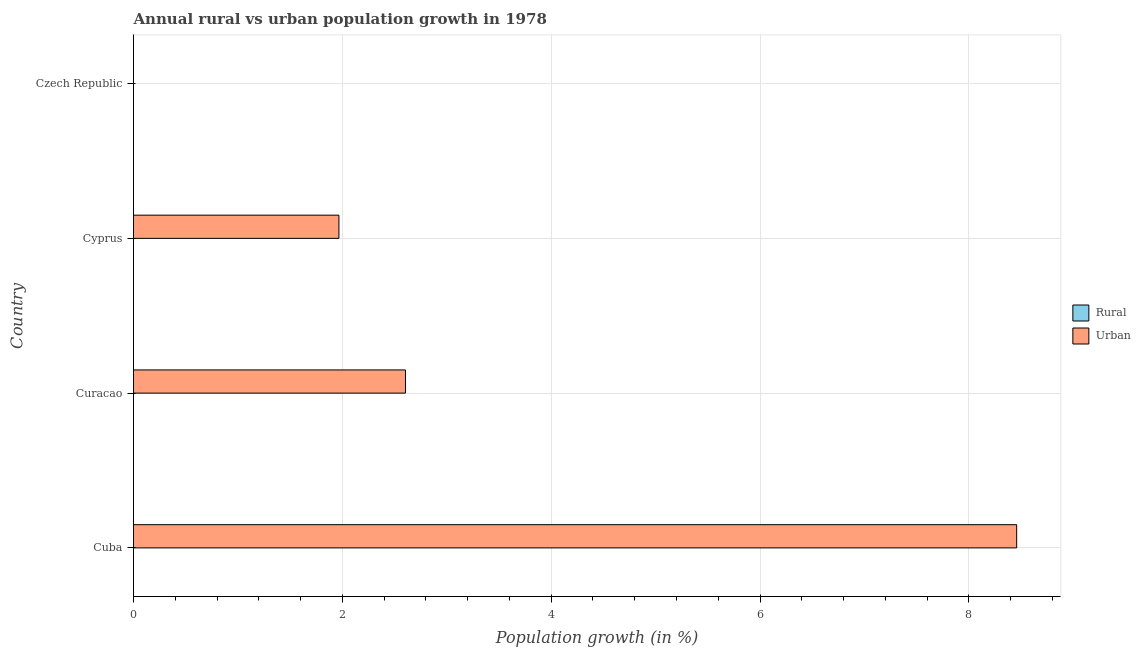How many different coloured bars are there?
Provide a succinct answer. 1. Are the number of bars per tick equal to the number of legend labels?
Your answer should be compact. No. How many bars are there on the 2nd tick from the bottom?
Offer a very short reply. 1. What is the label of the 1st group of bars from the top?
Ensure brevity in your answer.  Czech Republic. In how many cases, is the number of bars for a given country not equal to the number of legend labels?
Make the answer very short. 4. What is the urban population growth in Curacao?
Your answer should be compact. 2.6. Across all countries, what is the maximum urban population growth?
Offer a very short reply. 8.46. Across all countries, what is the minimum urban population growth?
Offer a very short reply. 0. In which country was the urban population growth maximum?
Your answer should be very brief. Cuba. What is the total urban population growth in the graph?
Your answer should be very brief. 13.03. What is the difference between the urban population growth in Curacao and that in Cyprus?
Offer a very short reply. 0.64. What is the difference between the urban population growth in Curacao and the rural population growth in Cuba?
Ensure brevity in your answer.  2.6. In how many countries, is the rural population growth greater than 2 %?
Give a very brief answer. 0. What is the difference between the highest and the second highest urban population growth?
Your response must be concise. 5.85. What is the difference between the highest and the lowest urban population growth?
Offer a terse response. 8.46. Is the sum of the urban population growth in Cuba and Cyprus greater than the maximum rural population growth across all countries?
Offer a terse response. Yes. How many bars are there?
Your answer should be very brief. 3. Are all the bars in the graph horizontal?
Offer a very short reply. Yes. How many countries are there in the graph?
Provide a succinct answer. 4. What is the difference between two consecutive major ticks on the X-axis?
Your answer should be compact. 2. Where does the legend appear in the graph?
Ensure brevity in your answer.  Center right. How are the legend labels stacked?
Give a very brief answer. Vertical. What is the title of the graph?
Ensure brevity in your answer.  Annual rural vs urban population growth in 1978. What is the label or title of the X-axis?
Your answer should be compact. Population growth (in %). What is the label or title of the Y-axis?
Ensure brevity in your answer.  Country. What is the Population growth (in %) of Urban  in Cuba?
Your answer should be very brief. 8.46. What is the Population growth (in %) of Rural in Curacao?
Keep it short and to the point. 0. What is the Population growth (in %) of Urban  in Curacao?
Provide a succinct answer. 2.6. What is the Population growth (in %) in Urban  in Cyprus?
Ensure brevity in your answer.  1.97. What is the Population growth (in %) in Rural in Czech Republic?
Offer a very short reply. 0. Across all countries, what is the maximum Population growth (in %) of Urban ?
Give a very brief answer. 8.46. What is the total Population growth (in %) in Urban  in the graph?
Provide a short and direct response. 13.03. What is the difference between the Population growth (in %) of Urban  in Cuba and that in Curacao?
Your answer should be very brief. 5.85. What is the difference between the Population growth (in %) in Urban  in Cuba and that in Cyprus?
Make the answer very short. 6.49. What is the difference between the Population growth (in %) of Urban  in Curacao and that in Cyprus?
Offer a terse response. 0.64. What is the average Population growth (in %) in Urban  per country?
Keep it short and to the point. 3.26. What is the ratio of the Population growth (in %) in Urban  in Cuba to that in Curacao?
Give a very brief answer. 3.25. What is the ratio of the Population growth (in %) of Urban  in Cuba to that in Cyprus?
Keep it short and to the point. 4.3. What is the ratio of the Population growth (in %) in Urban  in Curacao to that in Cyprus?
Offer a very short reply. 1.32. What is the difference between the highest and the second highest Population growth (in %) in Urban ?
Your answer should be very brief. 5.85. What is the difference between the highest and the lowest Population growth (in %) in Urban ?
Your response must be concise. 8.46. 